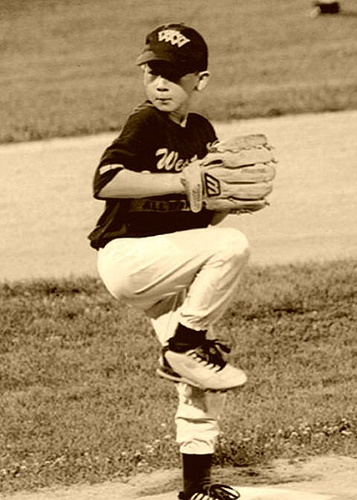Describe the objects in this image and their specific colors. I can see people in olive, black, tan, and lightyellow tones and baseball glove in olive and tan tones in this image. 